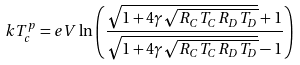Convert formula to latex. <formula><loc_0><loc_0><loc_500><loc_500>k T _ { c } ^ { p } = e V \ln \left ( \frac { \sqrt { 1 + 4 \gamma \sqrt { R _ { C } T _ { C } R _ { D } T _ { D } } } + 1 } { \sqrt { 1 + 4 \gamma \sqrt { R _ { C } T _ { C } R _ { D } T _ { D } } } - 1 } \right )</formula> 